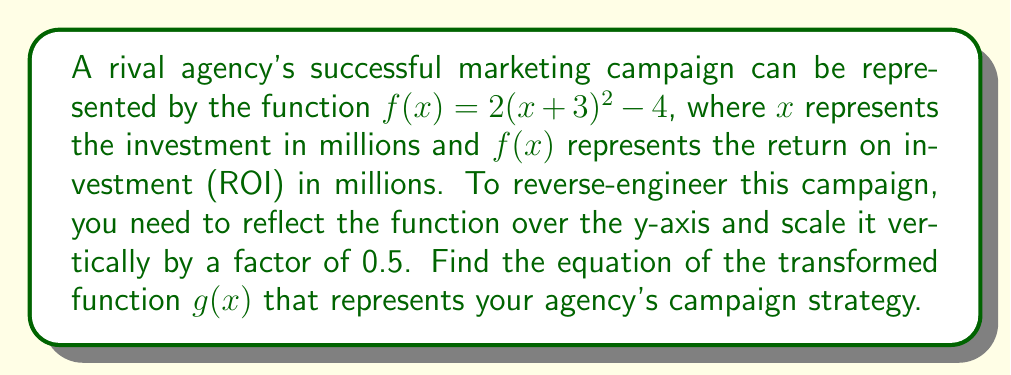Provide a solution to this math problem. To reverse-engineer the rival's campaign, we need to apply two transformations to the original function $f(x) = 2(x+3)^2 - 4$:

1. Reflection over the y-axis:
   This transformation changes $x$ to $-x$ in the original function.
   $f(-x) = 2((-x)+3)^2 - 4 = 2(-x+3)^2 - 4$

2. Vertical scaling by a factor of 0.5:
   This transformation multiplies the entire function by 0.5.
   $0.5 \cdot f(-x) = 0.5(2(-x+3)^2 - 4) = ((-x+3)^2 - 2)$

Now, let's simplify the transformed function:

$$\begin{align}
g(x) &= ((-x+3)^2 - 2) \\
&= (x-3)^2 - 2 \\
&= x^2 - 6x + 9 - 2 \\
&= x^2 - 6x + 7
\end{align}$$

Therefore, the equation of the transformed function $g(x)$ that represents your agency's campaign strategy is $g(x) = x^2 - 6x + 7$.
Answer: $g(x) = x^2 - 6x + 7$ 